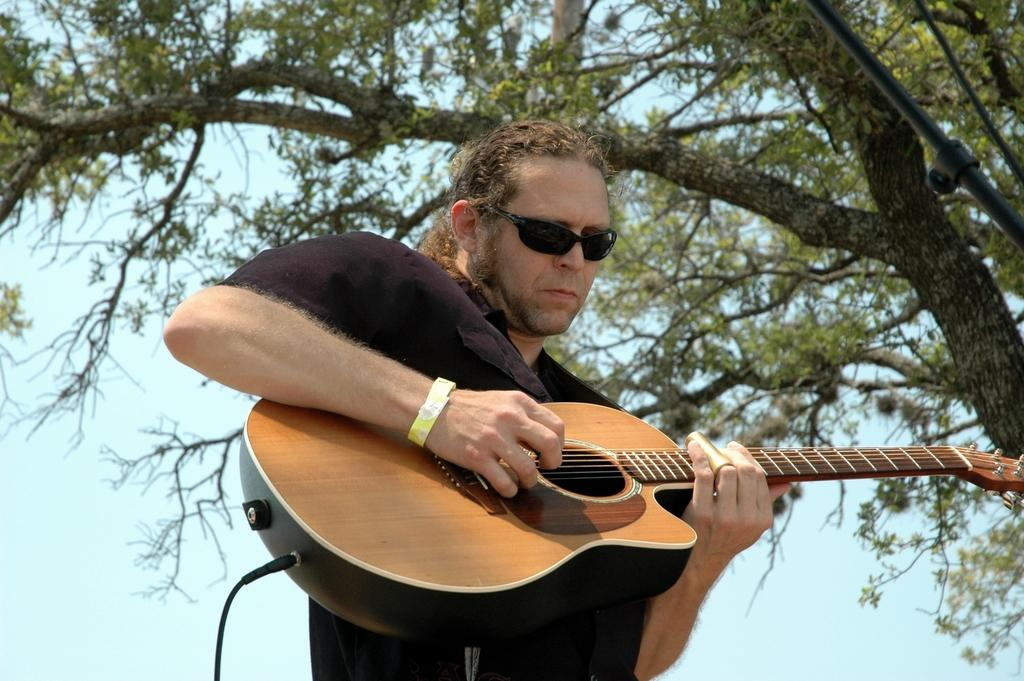What is the man in the image doing? The man is playing a guitar in the image. What can be seen beside the man? There is a tree beside the man. What equipment is near the man? There is a microphone stand near the man. What is the condition of the sky in the image? The sky is clear and visible in the image. How many stars can be seen in the image? There are no stars visible in the image; it features a man playing a guitar, a tree, a microphone stand, and a clear sky. 